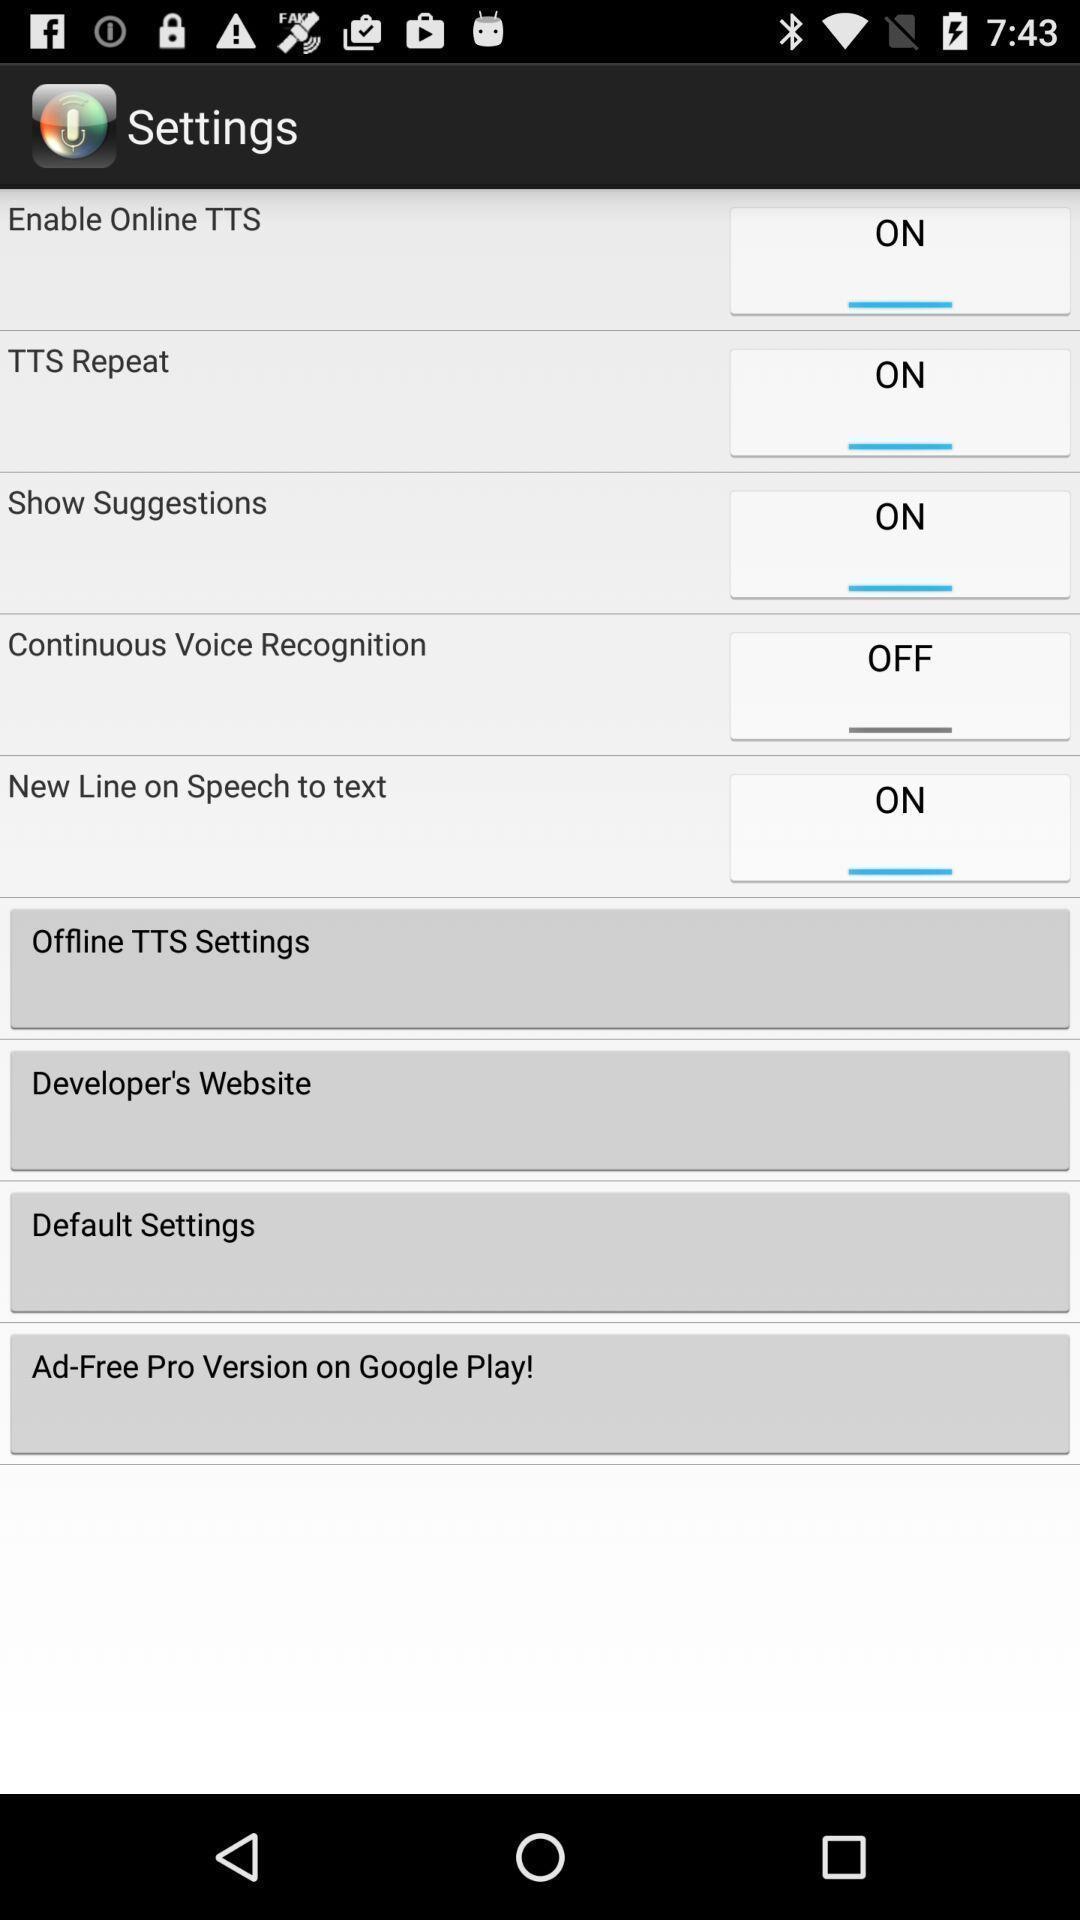Describe the key features of this screenshot. Screen displaying multiple setting options. 